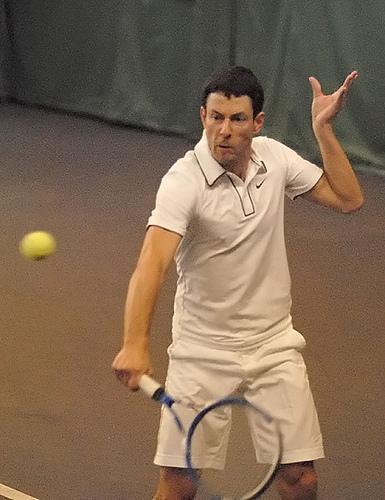How many wristbands does the man have on?
Give a very brief answer. 0. How many balls are there?
Give a very brief answer. 1. How many tennis rackets are in this scene?
Give a very brief answer. 1. How many of his fingers are extended?
Give a very brief answer. 5. 